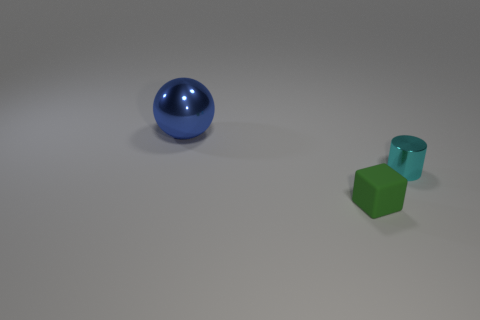Add 3 red matte blocks. How many objects exist? 6 Subtract all spheres. How many objects are left? 2 Subtract all large metal spheres. Subtract all green shiny blocks. How many objects are left? 2 Add 2 large objects. How many large objects are left? 3 Add 1 shiny cylinders. How many shiny cylinders exist? 2 Subtract 0 red cubes. How many objects are left? 3 